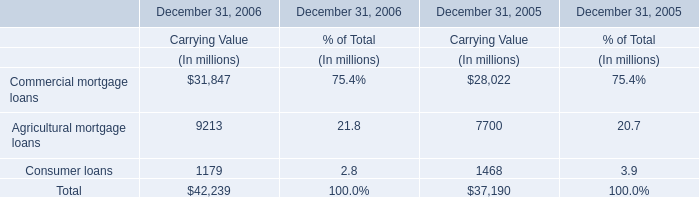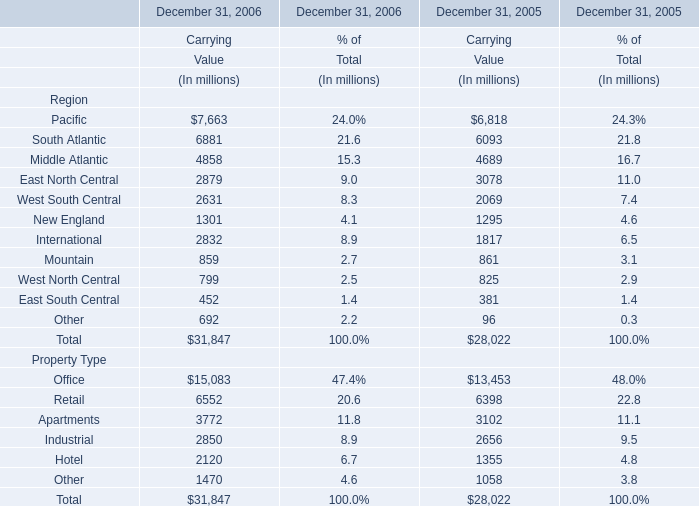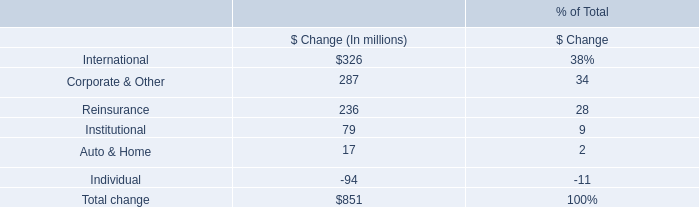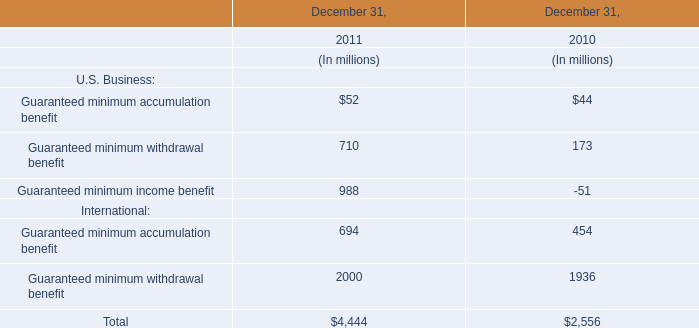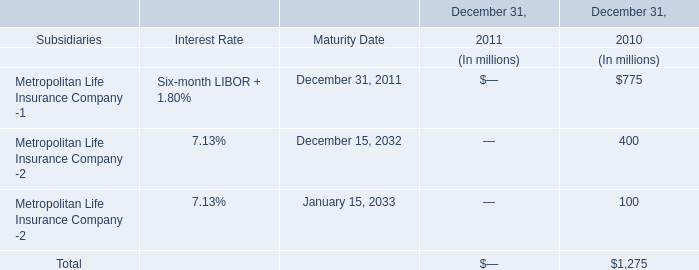What was the average value of Commercial mortgage loans, Agricultural mortgage loans, Consumer loans in 2005,in terms of Carrying Value? (in million) 
Computations: (((28022 + 7700) + 1468) / 3)
Answer: 12396.66667. 